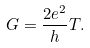Convert formula to latex. <formula><loc_0><loc_0><loc_500><loc_500>G = \frac { 2 e ^ { 2 } } { h } T .</formula> 